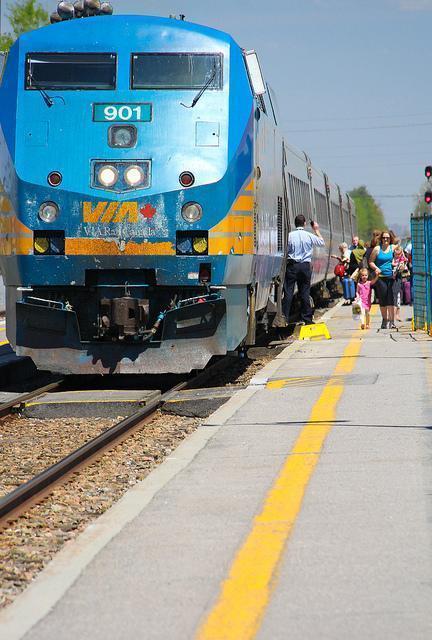What is the occupation of the man on the yellow step?
Indicate the correct response and explain using: 'Answer: answer
Rationale: rationale.'
Options: Waiter, musician, doctor, conductor. Answer: conductor.
Rationale: He's the conductor. 